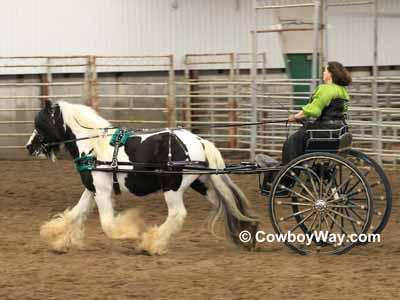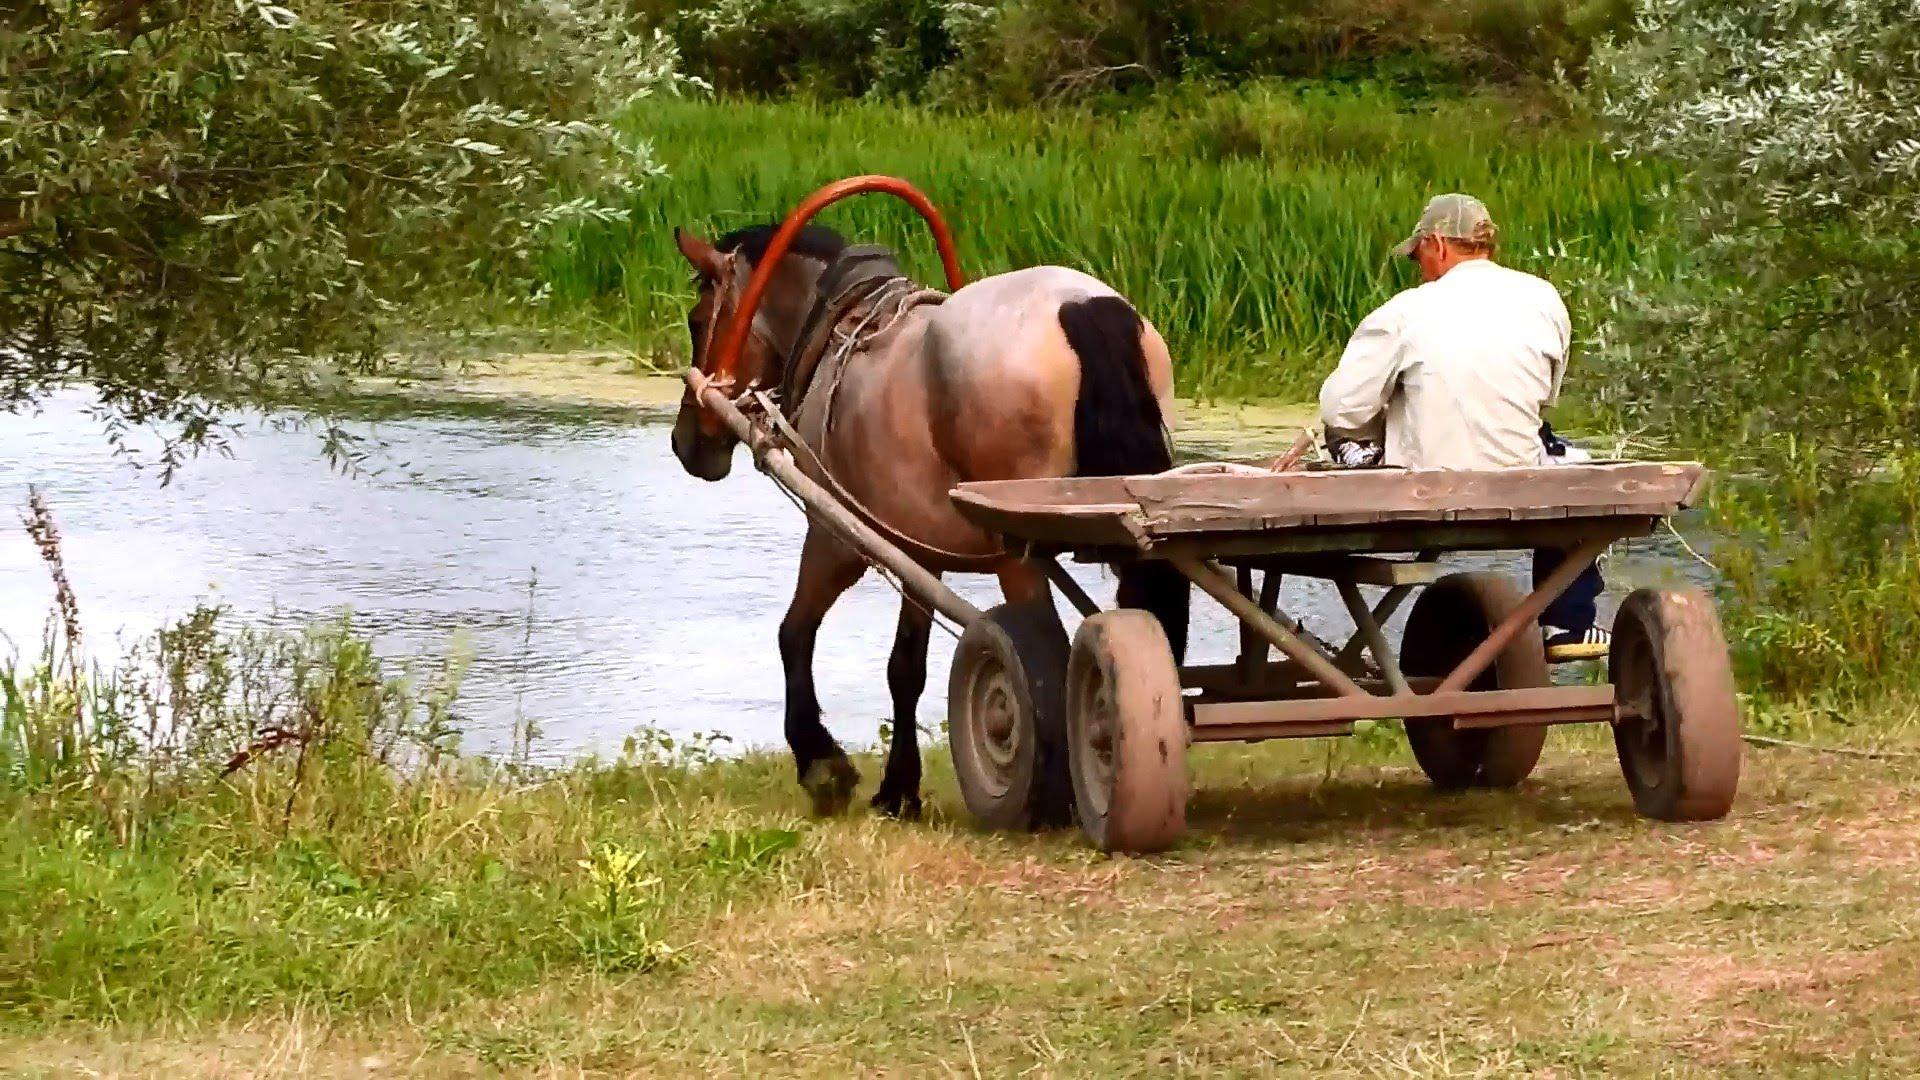The first image is the image on the left, the second image is the image on the right. For the images shown, is this caption "Both carts are pulled by brown horses." true? Answer yes or no. No. 